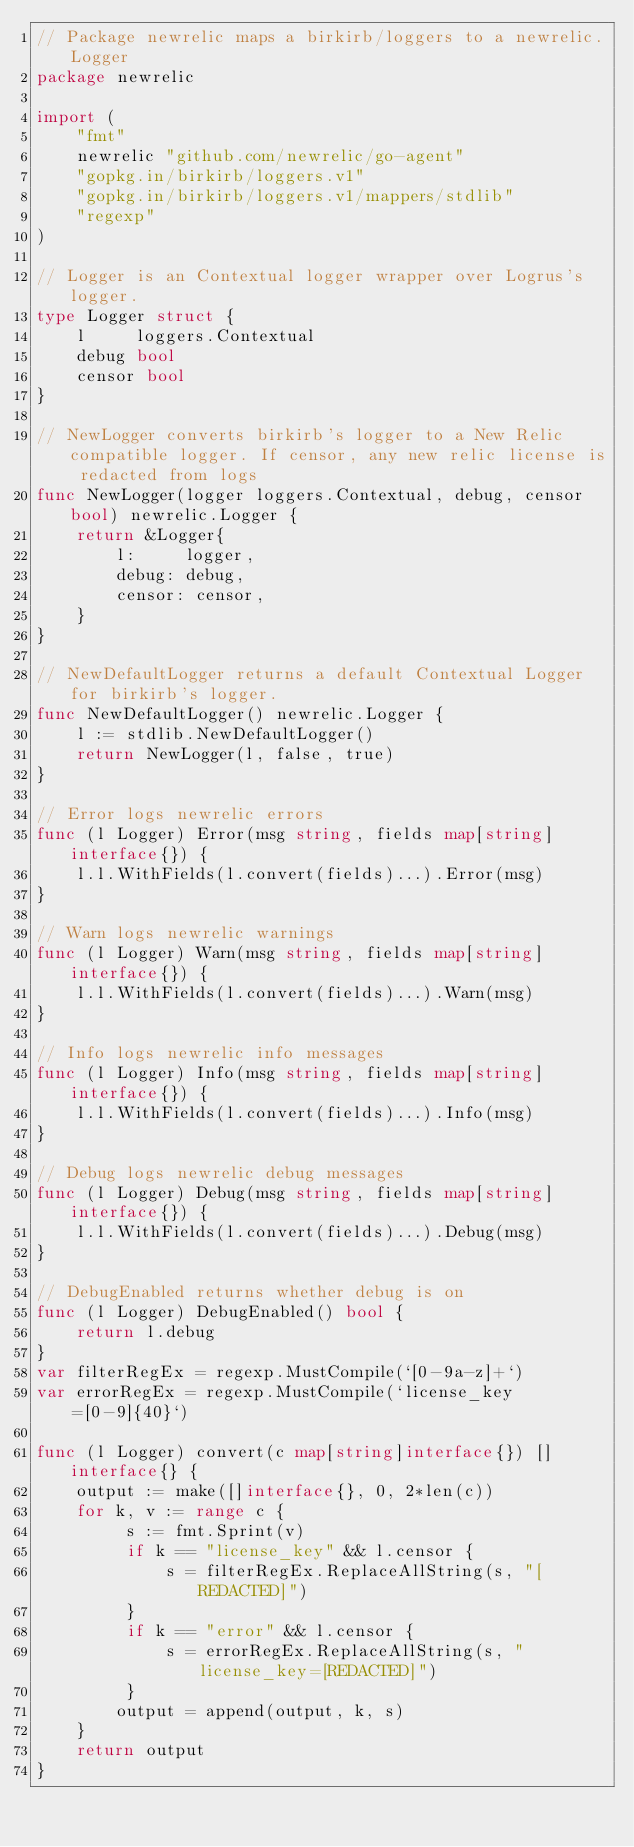<code> <loc_0><loc_0><loc_500><loc_500><_Go_>// Package newrelic maps a birkirb/loggers to a newrelic.Logger
package newrelic

import (
	"fmt"
	newrelic "github.com/newrelic/go-agent"
	"gopkg.in/birkirb/loggers.v1"
	"gopkg.in/birkirb/loggers.v1/mappers/stdlib"
	"regexp"
)

// Logger is an Contextual logger wrapper over Logrus's logger.
type Logger struct {
	l     loggers.Contextual
	debug bool
	censor bool
}

// NewLogger converts birkirb's logger to a New Relic compatible logger. If censor, any new relic license is redacted from logs
func NewLogger(logger loggers.Contextual, debug, censor bool) newrelic.Logger {
	return &Logger{
		l:     logger,
		debug: debug,
		censor: censor,
	}
}

// NewDefaultLogger returns a default Contextual Logger for birkirb's logger.
func NewDefaultLogger() newrelic.Logger {
	l := stdlib.NewDefaultLogger()
	return NewLogger(l, false, true)
}

// Error logs newrelic errors
func (l Logger) Error(msg string, fields map[string]interface{}) {
	l.l.WithFields(l.convert(fields)...).Error(msg)
}

// Warn logs newrelic warnings
func (l Logger) Warn(msg string, fields map[string]interface{}) {
	l.l.WithFields(l.convert(fields)...).Warn(msg)
}

// Info logs newrelic info messages
func (l Logger) Info(msg string, fields map[string]interface{}) {
	l.l.WithFields(l.convert(fields)...).Info(msg)
}

// Debug logs newrelic debug messages
func (l Logger) Debug(msg string, fields map[string]interface{}) {
	l.l.WithFields(l.convert(fields)...).Debug(msg)
}

// DebugEnabled returns whether debug is on
func (l Logger) DebugEnabled() bool {
	return l.debug
}
var filterRegEx = regexp.MustCompile(`[0-9a-z]+`)
var errorRegEx = regexp.MustCompile(`license_key=[0-9]{40}`)

func (l Logger) convert(c map[string]interface{}) []interface{} {
	output := make([]interface{}, 0, 2*len(c))
	for k, v := range c {
		 s := fmt.Sprint(v)
		 if k == "license_key" && l.censor {
			 s = filterRegEx.ReplaceAllString(s, "[REDACTED]")
		 }
		 if k == "error" && l.censor {
			 s = errorRegEx.ReplaceAllString(s, "license_key=[REDACTED]")
		 }
		output = append(output, k, s)
	}
	return output
}
</code> 